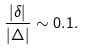Convert formula to latex. <formula><loc_0><loc_0><loc_500><loc_500>\frac { | \delta | } { | \Delta | } \sim 0 . 1 .</formula> 